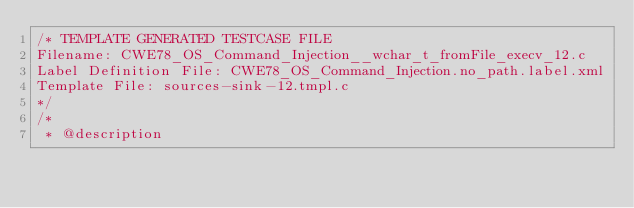<code> <loc_0><loc_0><loc_500><loc_500><_C_>/* TEMPLATE GENERATED TESTCASE FILE
Filename: CWE78_OS_Command_Injection__wchar_t_fromFile_execv_12.c
Label Definition File: CWE78_OS_Command_Injection.no_path.label.xml
Template File: sources-sink-12.tmpl.c
*/
/*
 * @description</code> 